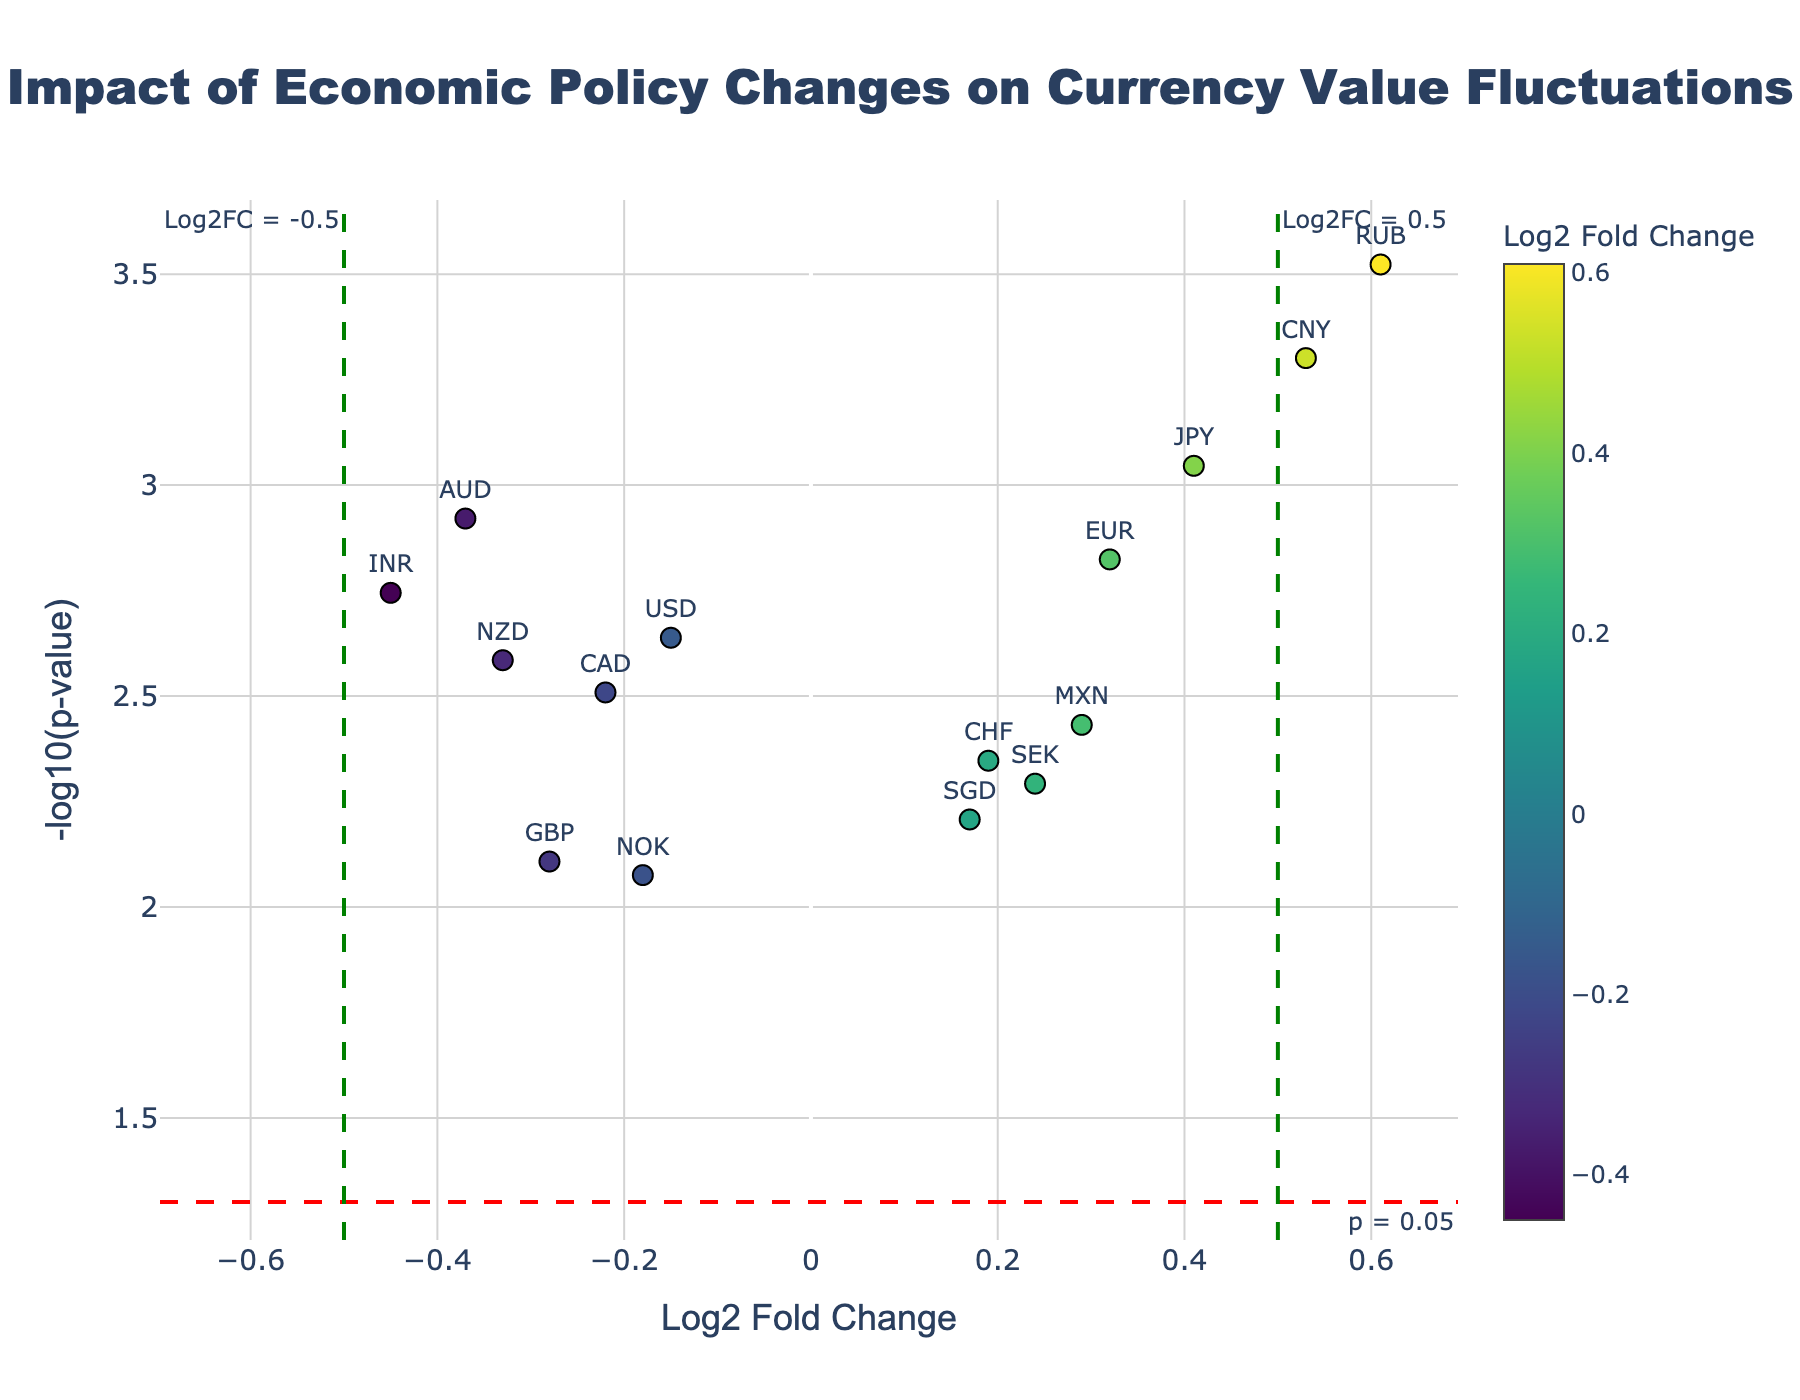What's the title of the volcano plot? The title typically appears at the top center of the plot and signifies what the visualization represents. In this case, the title is mentioned in the code snippet.
Answer: Impact of Economic Policy Changes on Currency Value Fluctuations How many currencies have a Log2FoldChange greater than 0.3? To find the answer, identify and count all data points whose x-axis value (Log2FoldChange) is greater than 0.3.
Answer: 2 Which currency shows the highest -log10(p-value)? Locate the data point that is the highest on the y-axis and note the corresponding currency name.
Answer: RUB Which currency's value decreased the most according to Log2FoldChange? Look for the data point with the most negative Log2FoldChange value on the x-axis.
Answer: INR How many currencies have a p-value less than 0.005? To determine this, count the number of currencies whose corresponding y-axis value (-log10(p-value)) is greater than -log10(0.005), which is approximately 2.301.
Answer: 7 What is the Log2FoldChange of GBP? Identify the data point labeled with GBP and use the x-axis to determine the Log2FoldChange.
Answer: -0.28 Compare the Log2FoldChange of JPY and CHF. Which one is higher? Locate the data points for JPY and CHF and compare their positions on the x-axis.
Answer: JPY For the currency CNY, is the p-value below the threshold of 0.05? Determine the y-axis position of the data point for CNY and compare it to where the threshold line (p = 0.05) has been drawn at approximately 1.301.
Answer: Yes Do any currencies fall exactly on the vertical threshold lines for Log2FoldChange (±0.5)? Check if any data points lie directly on x = -0.5 or x = 0.5.
Answer: No Which currency had the second-highest increase in value according to Log2FoldChange? First, identify the currencies with positive Log2FoldChange values. Then rank them in descending order and find the second highest.
Answer: CNY 